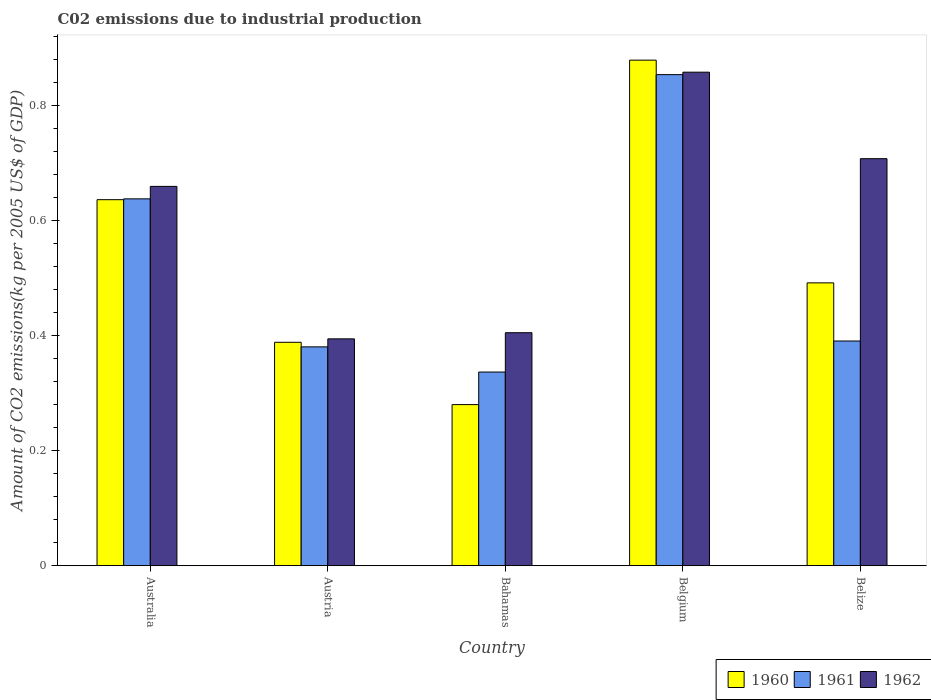How many different coloured bars are there?
Your response must be concise. 3. How many groups of bars are there?
Your response must be concise. 5. Are the number of bars per tick equal to the number of legend labels?
Provide a succinct answer. Yes. Are the number of bars on each tick of the X-axis equal?
Your answer should be very brief. Yes. How many bars are there on the 5th tick from the left?
Give a very brief answer. 3. In how many cases, is the number of bars for a given country not equal to the number of legend labels?
Provide a succinct answer. 0. What is the amount of CO2 emitted due to industrial production in 1961 in Austria?
Your answer should be very brief. 0.38. Across all countries, what is the maximum amount of CO2 emitted due to industrial production in 1961?
Provide a succinct answer. 0.85. Across all countries, what is the minimum amount of CO2 emitted due to industrial production in 1962?
Provide a succinct answer. 0.39. In which country was the amount of CO2 emitted due to industrial production in 1962 maximum?
Offer a terse response. Belgium. In which country was the amount of CO2 emitted due to industrial production in 1960 minimum?
Your answer should be very brief. Bahamas. What is the total amount of CO2 emitted due to industrial production in 1960 in the graph?
Provide a succinct answer. 2.68. What is the difference between the amount of CO2 emitted due to industrial production in 1960 in Bahamas and that in Belize?
Give a very brief answer. -0.21. What is the difference between the amount of CO2 emitted due to industrial production in 1961 in Bahamas and the amount of CO2 emitted due to industrial production in 1960 in Belize?
Your answer should be very brief. -0.16. What is the average amount of CO2 emitted due to industrial production in 1960 per country?
Offer a very short reply. 0.54. What is the difference between the amount of CO2 emitted due to industrial production of/in 1962 and amount of CO2 emitted due to industrial production of/in 1960 in Austria?
Make the answer very short. 0.01. In how many countries, is the amount of CO2 emitted due to industrial production in 1961 greater than 0.24000000000000002 kg?
Ensure brevity in your answer.  5. What is the ratio of the amount of CO2 emitted due to industrial production in 1960 in Belgium to that in Belize?
Your answer should be very brief. 1.79. Is the amount of CO2 emitted due to industrial production in 1962 in Bahamas less than that in Belgium?
Your answer should be very brief. Yes. Is the difference between the amount of CO2 emitted due to industrial production in 1962 in Bahamas and Belgium greater than the difference between the amount of CO2 emitted due to industrial production in 1960 in Bahamas and Belgium?
Offer a very short reply. Yes. What is the difference between the highest and the second highest amount of CO2 emitted due to industrial production in 1961?
Your answer should be compact. 0.22. What is the difference between the highest and the lowest amount of CO2 emitted due to industrial production in 1960?
Your response must be concise. 0.6. What does the 1st bar from the right in Bahamas represents?
Give a very brief answer. 1962. Is it the case that in every country, the sum of the amount of CO2 emitted due to industrial production in 1962 and amount of CO2 emitted due to industrial production in 1960 is greater than the amount of CO2 emitted due to industrial production in 1961?
Your response must be concise. Yes. How many bars are there?
Provide a succinct answer. 15. How many countries are there in the graph?
Your response must be concise. 5. Does the graph contain any zero values?
Make the answer very short. No. Where does the legend appear in the graph?
Provide a succinct answer. Bottom right. How are the legend labels stacked?
Keep it short and to the point. Horizontal. What is the title of the graph?
Give a very brief answer. C02 emissions due to industrial production. What is the label or title of the X-axis?
Your answer should be compact. Country. What is the label or title of the Y-axis?
Offer a very short reply. Amount of CO2 emissions(kg per 2005 US$ of GDP). What is the Amount of CO2 emissions(kg per 2005 US$ of GDP) in 1960 in Australia?
Your answer should be compact. 0.64. What is the Amount of CO2 emissions(kg per 2005 US$ of GDP) in 1961 in Australia?
Give a very brief answer. 0.64. What is the Amount of CO2 emissions(kg per 2005 US$ of GDP) in 1962 in Australia?
Your answer should be compact. 0.66. What is the Amount of CO2 emissions(kg per 2005 US$ of GDP) of 1960 in Austria?
Make the answer very short. 0.39. What is the Amount of CO2 emissions(kg per 2005 US$ of GDP) of 1961 in Austria?
Keep it short and to the point. 0.38. What is the Amount of CO2 emissions(kg per 2005 US$ of GDP) of 1962 in Austria?
Offer a very short reply. 0.39. What is the Amount of CO2 emissions(kg per 2005 US$ of GDP) of 1960 in Bahamas?
Provide a short and direct response. 0.28. What is the Amount of CO2 emissions(kg per 2005 US$ of GDP) in 1961 in Bahamas?
Your answer should be compact. 0.34. What is the Amount of CO2 emissions(kg per 2005 US$ of GDP) in 1962 in Bahamas?
Ensure brevity in your answer.  0.41. What is the Amount of CO2 emissions(kg per 2005 US$ of GDP) of 1960 in Belgium?
Your answer should be very brief. 0.88. What is the Amount of CO2 emissions(kg per 2005 US$ of GDP) in 1961 in Belgium?
Offer a very short reply. 0.85. What is the Amount of CO2 emissions(kg per 2005 US$ of GDP) in 1962 in Belgium?
Make the answer very short. 0.86. What is the Amount of CO2 emissions(kg per 2005 US$ of GDP) of 1960 in Belize?
Give a very brief answer. 0.49. What is the Amount of CO2 emissions(kg per 2005 US$ of GDP) of 1961 in Belize?
Your response must be concise. 0.39. What is the Amount of CO2 emissions(kg per 2005 US$ of GDP) in 1962 in Belize?
Make the answer very short. 0.71. Across all countries, what is the maximum Amount of CO2 emissions(kg per 2005 US$ of GDP) in 1960?
Ensure brevity in your answer.  0.88. Across all countries, what is the maximum Amount of CO2 emissions(kg per 2005 US$ of GDP) of 1961?
Keep it short and to the point. 0.85. Across all countries, what is the maximum Amount of CO2 emissions(kg per 2005 US$ of GDP) in 1962?
Ensure brevity in your answer.  0.86. Across all countries, what is the minimum Amount of CO2 emissions(kg per 2005 US$ of GDP) of 1960?
Ensure brevity in your answer.  0.28. Across all countries, what is the minimum Amount of CO2 emissions(kg per 2005 US$ of GDP) in 1961?
Your response must be concise. 0.34. Across all countries, what is the minimum Amount of CO2 emissions(kg per 2005 US$ of GDP) of 1962?
Your answer should be very brief. 0.39. What is the total Amount of CO2 emissions(kg per 2005 US$ of GDP) of 1960 in the graph?
Make the answer very short. 2.68. What is the total Amount of CO2 emissions(kg per 2005 US$ of GDP) in 1961 in the graph?
Ensure brevity in your answer.  2.6. What is the total Amount of CO2 emissions(kg per 2005 US$ of GDP) in 1962 in the graph?
Keep it short and to the point. 3.03. What is the difference between the Amount of CO2 emissions(kg per 2005 US$ of GDP) in 1960 in Australia and that in Austria?
Give a very brief answer. 0.25. What is the difference between the Amount of CO2 emissions(kg per 2005 US$ of GDP) in 1961 in Australia and that in Austria?
Offer a terse response. 0.26. What is the difference between the Amount of CO2 emissions(kg per 2005 US$ of GDP) in 1962 in Australia and that in Austria?
Ensure brevity in your answer.  0.27. What is the difference between the Amount of CO2 emissions(kg per 2005 US$ of GDP) in 1960 in Australia and that in Bahamas?
Your answer should be very brief. 0.36. What is the difference between the Amount of CO2 emissions(kg per 2005 US$ of GDP) of 1961 in Australia and that in Bahamas?
Ensure brevity in your answer.  0.3. What is the difference between the Amount of CO2 emissions(kg per 2005 US$ of GDP) of 1962 in Australia and that in Bahamas?
Your response must be concise. 0.25. What is the difference between the Amount of CO2 emissions(kg per 2005 US$ of GDP) in 1960 in Australia and that in Belgium?
Your answer should be compact. -0.24. What is the difference between the Amount of CO2 emissions(kg per 2005 US$ of GDP) in 1961 in Australia and that in Belgium?
Your response must be concise. -0.22. What is the difference between the Amount of CO2 emissions(kg per 2005 US$ of GDP) of 1962 in Australia and that in Belgium?
Your answer should be very brief. -0.2. What is the difference between the Amount of CO2 emissions(kg per 2005 US$ of GDP) of 1960 in Australia and that in Belize?
Your answer should be compact. 0.14. What is the difference between the Amount of CO2 emissions(kg per 2005 US$ of GDP) of 1961 in Australia and that in Belize?
Make the answer very short. 0.25. What is the difference between the Amount of CO2 emissions(kg per 2005 US$ of GDP) in 1962 in Australia and that in Belize?
Provide a short and direct response. -0.05. What is the difference between the Amount of CO2 emissions(kg per 2005 US$ of GDP) of 1960 in Austria and that in Bahamas?
Keep it short and to the point. 0.11. What is the difference between the Amount of CO2 emissions(kg per 2005 US$ of GDP) in 1961 in Austria and that in Bahamas?
Your response must be concise. 0.04. What is the difference between the Amount of CO2 emissions(kg per 2005 US$ of GDP) in 1962 in Austria and that in Bahamas?
Provide a succinct answer. -0.01. What is the difference between the Amount of CO2 emissions(kg per 2005 US$ of GDP) of 1960 in Austria and that in Belgium?
Your response must be concise. -0.49. What is the difference between the Amount of CO2 emissions(kg per 2005 US$ of GDP) of 1961 in Austria and that in Belgium?
Give a very brief answer. -0.47. What is the difference between the Amount of CO2 emissions(kg per 2005 US$ of GDP) of 1962 in Austria and that in Belgium?
Your answer should be very brief. -0.46. What is the difference between the Amount of CO2 emissions(kg per 2005 US$ of GDP) of 1960 in Austria and that in Belize?
Your response must be concise. -0.1. What is the difference between the Amount of CO2 emissions(kg per 2005 US$ of GDP) of 1961 in Austria and that in Belize?
Offer a very short reply. -0.01. What is the difference between the Amount of CO2 emissions(kg per 2005 US$ of GDP) in 1962 in Austria and that in Belize?
Provide a short and direct response. -0.31. What is the difference between the Amount of CO2 emissions(kg per 2005 US$ of GDP) of 1960 in Bahamas and that in Belgium?
Provide a succinct answer. -0.6. What is the difference between the Amount of CO2 emissions(kg per 2005 US$ of GDP) in 1961 in Bahamas and that in Belgium?
Provide a short and direct response. -0.52. What is the difference between the Amount of CO2 emissions(kg per 2005 US$ of GDP) of 1962 in Bahamas and that in Belgium?
Keep it short and to the point. -0.45. What is the difference between the Amount of CO2 emissions(kg per 2005 US$ of GDP) of 1960 in Bahamas and that in Belize?
Your answer should be very brief. -0.21. What is the difference between the Amount of CO2 emissions(kg per 2005 US$ of GDP) in 1961 in Bahamas and that in Belize?
Make the answer very short. -0.05. What is the difference between the Amount of CO2 emissions(kg per 2005 US$ of GDP) in 1962 in Bahamas and that in Belize?
Make the answer very short. -0.3. What is the difference between the Amount of CO2 emissions(kg per 2005 US$ of GDP) of 1960 in Belgium and that in Belize?
Ensure brevity in your answer.  0.39. What is the difference between the Amount of CO2 emissions(kg per 2005 US$ of GDP) of 1961 in Belgium and that in Belize?
Offer a very short reply. 0.46. What is the difference between the Amount of CO2 emissions(kg per 2005 US$ of GDP) of 1962 in Belgium and that in Belize?
Keep it short and to the point. 0.15. What is the difference between the Amount of CO2 emissions(kg per 2005 US$ of GDP) in 1960 in Australia and the Amount of CO2 emissions(kg per 2005 US$ of GDP) in 1961 in Austria?
Make the answer very short. 0.26. What is the difference between the Amount of CO2 emissions(kg per 2005 US$ of GDP) of 1960 in Australia and the Amount of CO2 emissions(kg per 2005 US$ of GDP) of 1962 in Austria?
Keep it short and to the point. 0.24. What is the difference between the Amount of CO2 emissions(kg per 2005 US$ of GDP) of 1961 in Australia and the Amount of CO2 emissions(kg per 2005 US$ of GDP) of 1962 in Austria?
Your answer should be very brief. 0.24. What is the difference between the Amount of CO2 emissions(kg per 2005 US$ of GDP) in 1960 in Australia and the Amount of CO2 emissions(kg per 2005 US$ of GDP) in 1961 in Bahamas?
Your answer should be very brief. 0.3. What is the difference between the Amount of CO2 emissions(kg per 2005 US$ of GDP) in 1960 in Australia and the Amount of CO2 emissions(kg per 2005 US$ of GDP) in 1962 in Bahamas?
Provide a succinct answer. 0.23. What is the difference between the Amount of CO2 emissions(kg per 2005 US$ of GDP) of 1961 in Australia and the Amount of CO2 emissions(kg per 2005 US$ of GDP) of 1962 in Bahamas?
Make the answer very short. 0.23. What is the difference between the Amount of CO2 emissions(kg per 2005 US$ of GDP) in 1960 in Australia and the Amount of CO2 emissions(kg per 2005 US$ of GDP) in 1961 in Belgium?
Your response must be concise. -0.22. What is the difference between the Amount of CO2 emissions(kg per 2005 US$ of GDP) of 1960 in Australia and the Amount of CO2 emissions(kg per 2005 US$ of GDP) of 1962 in Belgium?
Ensure brevity in your answer.  -0.22. What is the difference between the Amount of CO2 emissions(kg per 2005 US$ of GDP) of 1961 in Australia and the Amount of CO2 emissions(kg per 2005 US$ of GDP) of 1962 in Belgium?
Give a very brief answer. -0.22. What is the difference between the Amount of CO2 emissions(kg per 2005 US$ of GDP) of 1960 in Australia and the Amount of CO2 emissions(kg per 2005 US$ of GDP) of 1961 in Belize?
Provide a short and direct response. 0.25. What is the difference between the Amount of CO2 emissions(kg per 2005 US$ of GDP) of 1960 in Australia and the Amount of CO2 emissions(kg per 2005 US$ of GDP) of 1962 in Belize?
Keep it short and to the point. -0.07. What is the difference between the Amount of CO2 emissions(kg per 2005 US$ of GDP) in 1961 in Australia and the Amount of CO2 emissions(kg per 2005 US$ of GDP) in 1962 in Belize?
Provide a succinct answer. -0.07. What is the difference between the Amount of CO2 emissions(kg per 2005 US$ of GDP) in 1960 in Austria and the Amount of CO2 emissions(kg per 2005 US$ of GDP) in 1961 in Bahamas?
Provide a succinct answer. 0.05. What is the difference between the Amount of CO2 emissions(kg per 2005 US$ of GDP) in 1960 in Austria and the Amount of CO2 emissions(kg per 2005 US$ of GDP) in 1962 in Bahamas?
Provide a succinct answer. -0.02. What is the difference between the Amount of CO2 emissions(kg per 2005 US$ of GDP) in 1961 in Austria and the Amount of CO2 emissions(kg per 2005 US$ of GDP) in 1962 in Bahamas?
Give a very brief answer. -0.02. What is the difference between the Amount of CO2 emissions(kg per 2005 US$ of GDP) of 1960 in Austria and the Amount of CO2 emissions(kg per 2005 US$ of GDP) of 1961 in Belgium?
Ensure brevity in your answer.  -0.47. What is the difference between the Amount of CO2 emissions(kg per 2005 US$ of GDP) in 1960 in Austria and the Amount of CO2 emissions(kg per 2005 US$ of GDP) in 1962 in Belgium?
Ensure brevity in your answer.  -0.47. What is the difference between the Amount of CO2 emissions(kg per 2005 US$ of GDP) of 1961 in Austria and the Amount of CO2 emissions(kg per 2005 US$ of GDP) of 1962 in Belgium?
Ensure brevity in your answer.  -0.48. What is the difference between the Amount of CO2 emissions(kg per 2005 US$ of GDP) in 1960 in Austria and the Amount of CO2 emissions(kg per 2005 US$ of GDP) in 1961 in Belize?
Provide a short and direct response. -0. What is the difference between the Amount of CO2 emissions(kg per 2005 US$ of GDP) in 1960 in Austria and the Amount of CO2 emissions(kg per 2005 US$ of GDP) in 1962 in Belize?
Your answer should be very brief. -0.32. What is the difference between the Amount of CO2 emissions(kg per 2005 US$ of GDP) in 1961 in Austria and the Amount of CO2 emissions(kg per 2005 US$ of GDP) in 1962 in Belize?
Your response must be concise. -0.33. What is the difference between the Amount of CO2 emissions(kg per 2005 US$ of GDP) in 1960 in Bahamas and the Amount of CO2 emissions(kg per 2005 US$ of GDP) in 1961 in Belgium?
Your answer should be very brief. -0.57. What is the difference between the Amount of CO2 emissions(kg per 2005 US$ of GDP) of 1960 in Bahamas and the Amount of CO2 emissions(kg per 2005 US$ of GDP) of 1962 in Belgium?
Make the answer very short. -0.58. What is the difference between the Amount of CO2 emissions(kg per 2005 US$ of GDP) of 1961 in Bahamas and the Amount of CO2 emissions(kg per 2005 US$ of GDP) of 1962 in Belgium?
Offer a terse response. -0.52. What is the difference between the Amount of CO2 emissions(kg per 2005 US$ of GDP) of 1960 in Bahamas and the Amount of CO2 emissions(kg per 2005 US$ of GDP) of 1961 in Belize?
Your answer should be very brief. -0.11. What is the difference between the Amount of CO2 emissions(kg per 2005 US$ of GDP) of 1960 in Bahamas and the Amount of CO2 emissions(kg per 2005 US$ of GDP) of 1962 in Belize?
Give a very brief answer. -0.43. What is the difference between the Amount of CO2 emissions(kg per 2005 US$ of GDP) of 1961 in Bahamas and the Amount of CO2 emissions(kg per 2005 US$ of GDP) of 1962 in Belize?
Make the answer very short. -0.37. What is the difference between the Amount of CO2 emissions(kg per 2005 US$ of GDP) of 1960 in Belgium and the Amount of CO2 emissions(kg per 2005 US$ of GDP) of 1961 in Belize?
Offer a terse response. 0.49. What is the difference between the Amount of CO2 emissions(kg per 2005 US$ of GDP) of 1960 in Belgium and the Amount of CO2 emissions(kg per 2005 US$ of GDP) of 1962 in Belize?
Keep it short and to the point. 0.17. What is the difference between the Amount of CO2 emissions(kg per 2005 US$ of GDP) of 1961 in Belgium and the Amount of CO2 emissions(kg per 2005 US$ of GDP) of 1962 in Belize?
Provide a short and direct response. 0.15. What is the average Amount of CO2 emissions(kg per 2005 US$ of GDP) of 1960 per country?
Provide a short and direct response. 0.54. What is the average Amount of CO2 emissions(kg per 2005 US$ of GDP) in 1961 per country?
Your answer should be compact. 0.52. What is the average Amount of CO2 emissions(kg per 2005 US$ of GDP) in 1962 per country?
Offer a very short reply. 0.61. What is the difference between the Amount of CO2 emissions(kg per 2005 US$ of GDP) in 1960 and Amount of CO2 emissions(kg per 2005 US$ of GDP) in 1961 in Australia?
Provide a succinct answer. -0. What is the difference between the Amount of CO2 emissions(kg per 2005 US$ of GDP) in 1960 and Amount of CO2 emissions(kg per 2005 US$ of GDP) in 1962 in Australia?
Give a very brief answer. -0.02. What is the difference between the Amount of CO2 emissions(kg per 2005 US$ of GDP) in 1961 and Amount of CO2 emissions(kg per 2005 US$ of GDP) in 1962 in Australia?
Keep it short and to the point. -0.02. What is the difference between the Amount of CO2 emissions(kg per 2005 US$ of GDP) of 1960 and Amount of CO2 emissions(kg per 2005 US$ of GDP) of 1961 in Austria?
Your answer should be compact. 0.01. What is the difference between the Amount of CO2 emissions(kg per 2005 US$ of GDP) in 1960 and Amount of CO2 emissions(kg per 2005 US$ of GDP) in 1962 in Austria?
Your answer should be very brief. -0.01. What is the difference between the Amount of CO2 emissions(kg per 2005 US$ of GDP) of 1961 and Amount of CO2 emissions(kg per 2005 US$ of GDP) of 1962 in Austria?
Keep it short and to the point. -0.01. What is the difference between the Amount of CO2 emissions(kg per 2005 US$ of GDP) of 1960 and Amount of CO2 emissions(kg per 2005 US$ of GDP) of 1961 in Bahamas?
Offer a very short reply. -0.06. What is the difference between the Amount of CO2 emissions(kg per 2005 US$ of GDP) of 1960 and Amount of CO2 emissions(kg per 2005 US$ of GDP) of 1962 in Bahamas?
Your response must be concise. -0.13. What is the difference between the Amount of CO2 emissions(kg per 2005 US$ of GDP) in 1961 and Amount of CO2 emissions(kg per 2005 US$ of GDP) in 1962 in Bahamas?
Offer a terse response. -0.07. What is the difference between the Amount of CO2 emissions(kg per 2005 US$ of GDP) of 1960 and Amount of CO2 emissions(kg per 2005 US$ of GDP) of 1961 in Belgium?
Offer a terse response. 0.03. What is the difference between the Amount of CO2 emissions(kg per 2005 US$ of GDP) in 1960 and Amount of CO2 emissions(kg per 2005 US$ of GDP) in 1962 in Belgium?
Your answer should be very brief. 0.02. What is the difference between the Amount of CO2 emissions(kg per 2005 US$ of GDP) in 1961 and Amount of CO2 emissions(kg per 2005 US$ of GDP) in 1962 in Belgium?
Make the answer very short. -0. What is the difference between the Amount of CO2 emissions(kg per 2005 US$ of GDP) of 1960 and Amount of CO2 emissions(kg per 2005 US$ of GDP) of 1961 in Belize?
Give a very brief answer. 0.1. What is the difference between the Amount of CO2 emissions(kg per 2005 US$ of GDP) of 1960 and Amount of CO2 emissions(kg per 2005 US$ of GDP) of 1962 in Belize?
Ensure brevity in your answer.  -0.22. What is the difference between the Amount of CO2 emissions(kg per 2005 US$ of GDP) in 1961 and Amount of CO2 emissions(kg per 2005 US$ of GDP) in 1962 in Belize?
Give a very brief answer. -0.32. What is the ratio of the Amount of CO2 emissions(kg per 2005 US$ of GDP) in 1960 in Australia to that in Austria?
Offer a terse response. 1.64. What is the ratio of the Amount of CO2 emissions(kg per 2005 US$ of GDP) in 1961 in Australia to that in Austria?
Provide a short and direct response. 1.68. What is the ratio of the Amount of CO2 emissions(kg per 2005 US$ of GDP) of 1962 in Australia to that in Austria?
Your answer should be very brief. 1.67. What is the ratio of the Amount of CO2 emissions(kg per 2005 US$ of GDP) of 1960 in Australia to that in Bahamas?
Make the answer very short. 2.27. What is the ratio of the Amount of CO2 emissions(kg per 2005 US$ of GDP) in 1961 in Australia to that in Bahamas?
Offer a very short reply. 1.89. What is the ratio of the Amount of CO2 emissions(kg per 2005 US$ of GDP) of 1962 in Australia to that in Bahamas?
Your answer should be compact. 1.63. What is the ratio of the Amount of CO2 emissions(kg per 2005 US$ of GDP) in 1960 in Australia to that in Belgium?
Ensure brevity in your answer.  0.72. What is the ratio of the Amount of CO2 emissions(kg per 2005 US$ of GDP) of 1961 in Australia to that in Belgium?
Your answer should be compact. 0.75. What is the ratio of the Amount of CO2 emissions(kg per 2005 US$ of GDP) of 1962 in Australia to that in Belgium?
Offer a terse response. 0.77. What is the ratio of the Amount of CO2 emissions(kg per 2005 US$ of GDP) in 1960 in Australia to that in Belize?
Make the answer very short. 1.29. What is the ratio of the Amount of CO2 emissions(kg per 2005 US$ of GDP) in 1961 in Australia to that in Belize?
Give a very brief answer. 1.63. What is the ratio of the Amount of CO2 emissions(kg per 2005 US$ of GDP) of 1962 in Australia to that in Belize?
Your response must be concise. 0.93. What is the ratio of the Amount of CO2 emissions(kg per 2005 US$ of GDP) in 1960 in Austria to that in Bahamas?
Give a very brief answer. 1.39. What is the ratio of the Amount of CO2 emissions(kg per 2005 US$ of GDP) of 1961 in Austria to that in Bahamas?
Offer a terse response. 1.13. What is the ratio of the Amount of CO2 emissions(kg per 2005 US$ of GDP) in 1962 in Austria to that in Bahamas?
Provide a succinct answer. 0.97. What is the ratio of the Amount of CO2 emissions(kg per 2005 US$ of GDP) in 1960 in Austria to that in Belgium?
Keep it short and to the point. 0.44. What is the ratio of the Amount of CO2 emissions(kg per 2005 US$ of GDP) in 1961 in Austria to that in Belgium?
Provide a succinct answer. 0.45. What is the ratio of the Amount of CO2 emissions(kg per 2005 US$ of GDP) of 1962 in Austria to that in Belgium?
Give a very brief answer. 0.46. What is the ratio of the Amount of CO2 emissions(kg per 2005 US$ of GDP) in 1960 in Austria to that in Belize?
Provide a succinct answer. 0.79. What is the ratio of the Amount of CO2 emissions(kg per 2005 US$ of GDP) of 1961 in Austria to that in Belize?
Give a very brief answer. 0.97. What is the ratio of the Amount of CO2 emissions(kg per 2005 US$ of GDP) of 1962 in Austria to that in Belize?
Offer a terse response. 0.56. What is the ratio of the Amount of CO2 emissions(kg per 2005 US$ of GDP) of 1960 in Bahamas to that in Belgium?
Your response must be concise. 0.32. What is the ratio of the Amount of CO2 emissions(kg per 2005 US$ of GDP) in 1961 in Bahamas to that in Belgium?
Give a very brief answer. 0.39. What is the ratio of the Amount of CO2 emissions(kg per 2005 US$ of GDP) of 1962 in Bahamas to that in Belgium?
Keep it short and to the point. 0.47. What is the ratio of the Amount of CO2 emissions(kg per 2005 US$ of GDP) in 1960 in Bahamas to that in Belize?
Provide a short and direct response. 0.57. What is the ratio of the Amount of CO2 emissions(kg per 2005 US$ of GDP) of 1961 in Bahamas to that in Belize?
Provide a short and direct response. 0.86. What is the ratio of the Amount of CO2 emissions(kg per 2005 US$ of GDP) of 1962 in Bahamas to that in Belize?
Make the answer very short. 0.57. What is the ratio of the Amount of CO2 emissions(kg per 2005 US$ of GDP) of 1960 in Belgium to that in Belize?
Your answer should be compact. 1.79. What is the ratio of the Amount of CO2 emissions(kg per 2005 US$ of GDP) of 1961 in Belgium to that in Belize?
Provide a short and direct response. 2.19. What is the ratio of the Amount of CO2 emissions(kg per 2005 US$ of GDP) in 1962 in Belgium to that in Belize?
Ensure brevity in your answer.  1.21. What is the difference between the highest and the second highest Amount of CO2 emissions(kg per 2005 US$ of GDP) in 1960?
Give a very brief answer. 0.24. What is the difference between the highest and the second highest Amount of CO2 emissions(kg per 2005 US$ of GDP) in 1961?
Offer a very short reply. 0.22. What is the difference between the highest and the second highest Amount of CO2 emissions(kg per 2005 US$ of GDP) of 1962?
Your answer should be very brief. 0.15. What is the difference between the highest and the lowest Amount of CO2 emissions(kg per 2005 US$ of GDP) of 1960?
Ensure brevity in your answer.  0.6. What is the difference between the highest and the lowest Amount of CO2 emissions(kg per 2005 US$ of GDP) of 1961?
Give a very brief answer. 0.52. What is the difference between the highest and the lowest Amount of CO2 emissions(kg per 2005 US$ of GDP) in 1962?
Offer a terse response. 0.46. 